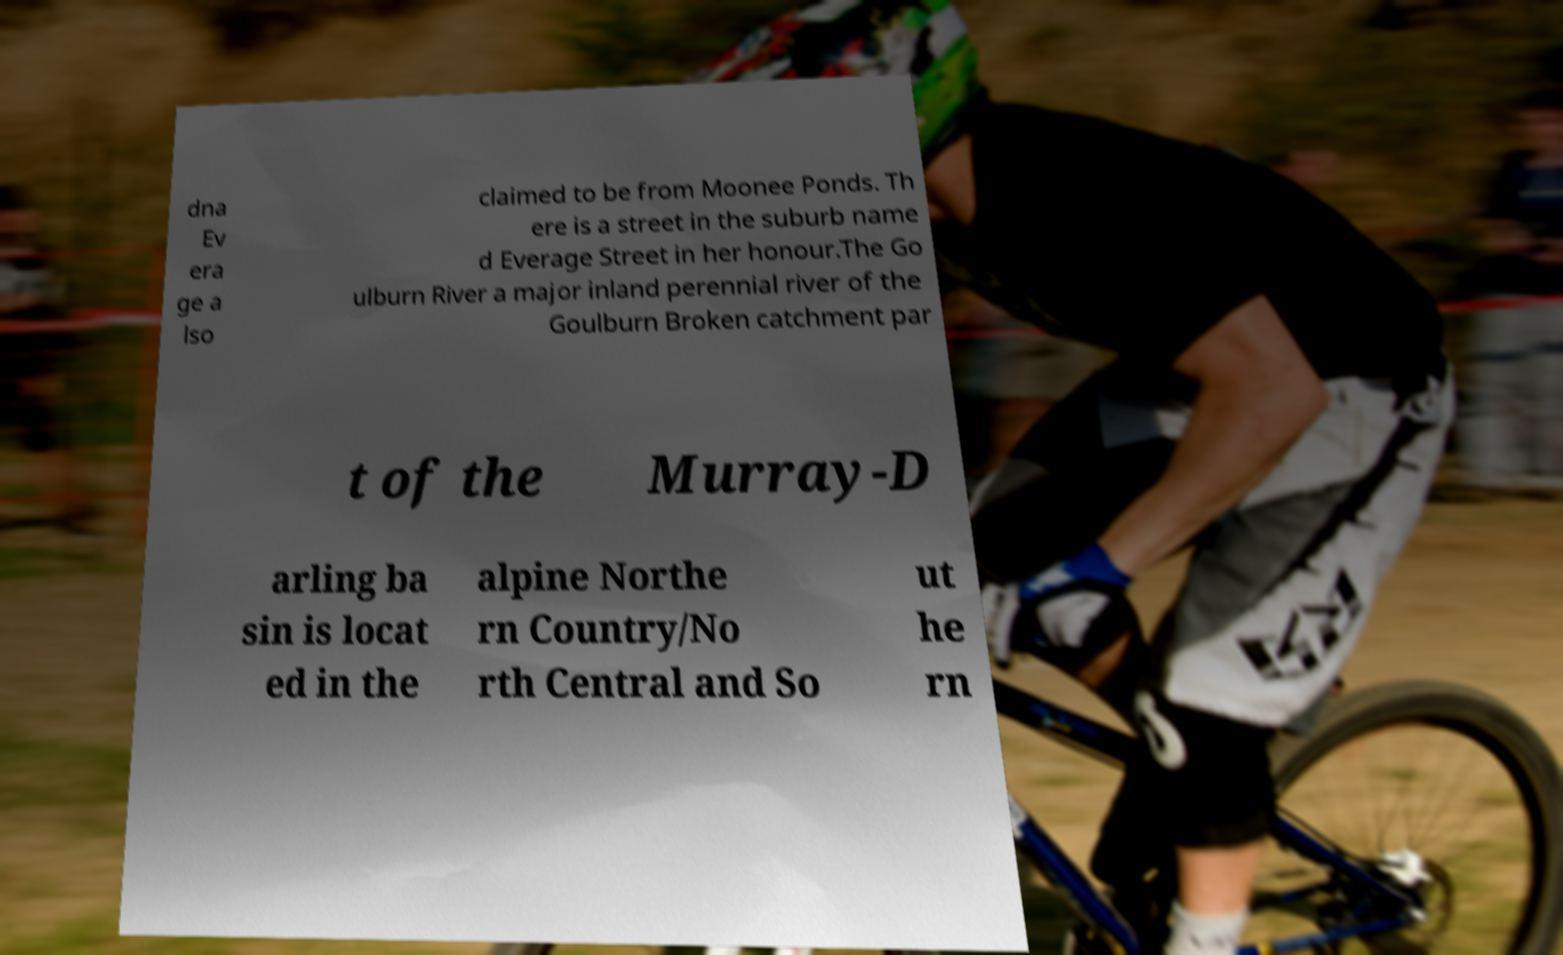For documentation purposes, I need the text within this image transcribed. Could you provide that? dna Ev era ge a lso claimed to be from Moonee Ponds. Th ere is a street in the suburb name d Everage Street in her honour.The Go ulburn River a major inland perennial river of the Goulburn Broken catchment par t of the Murray-D arling ba sin is locat ed in the alpine Northe rn Country/No rth Central and So ut he rn 